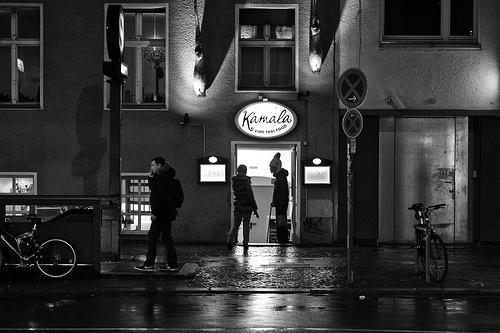Question: what is the name of the business?
Choices:
A. Bob's Burgers.
B. Walmart.
C. Makala.
D. Kamala.
Answer with the letter. Answer: D Question: who is walking away?
Choices:
A. Man.
B. A man.
C. A woman.
D. A dog.
Answer with the letter. Answer: A Question: where are the people?
Choices:
A. In the park.
B. In the river.
C. Under the tent.
D. Sidewalk.
Answer with the letter. Answer: D Question: when was the picture taken?
Choices:
A. Sunset.
B. Early Morning.
C. After lunch.
D. Nighttime.
Answer with the letter. Answer: D Question: why are there lights?
Choices:
A. It is night.
B. It is bright.
C. No windows.
D. It is dark.
Answer with the letter. Answer: D 